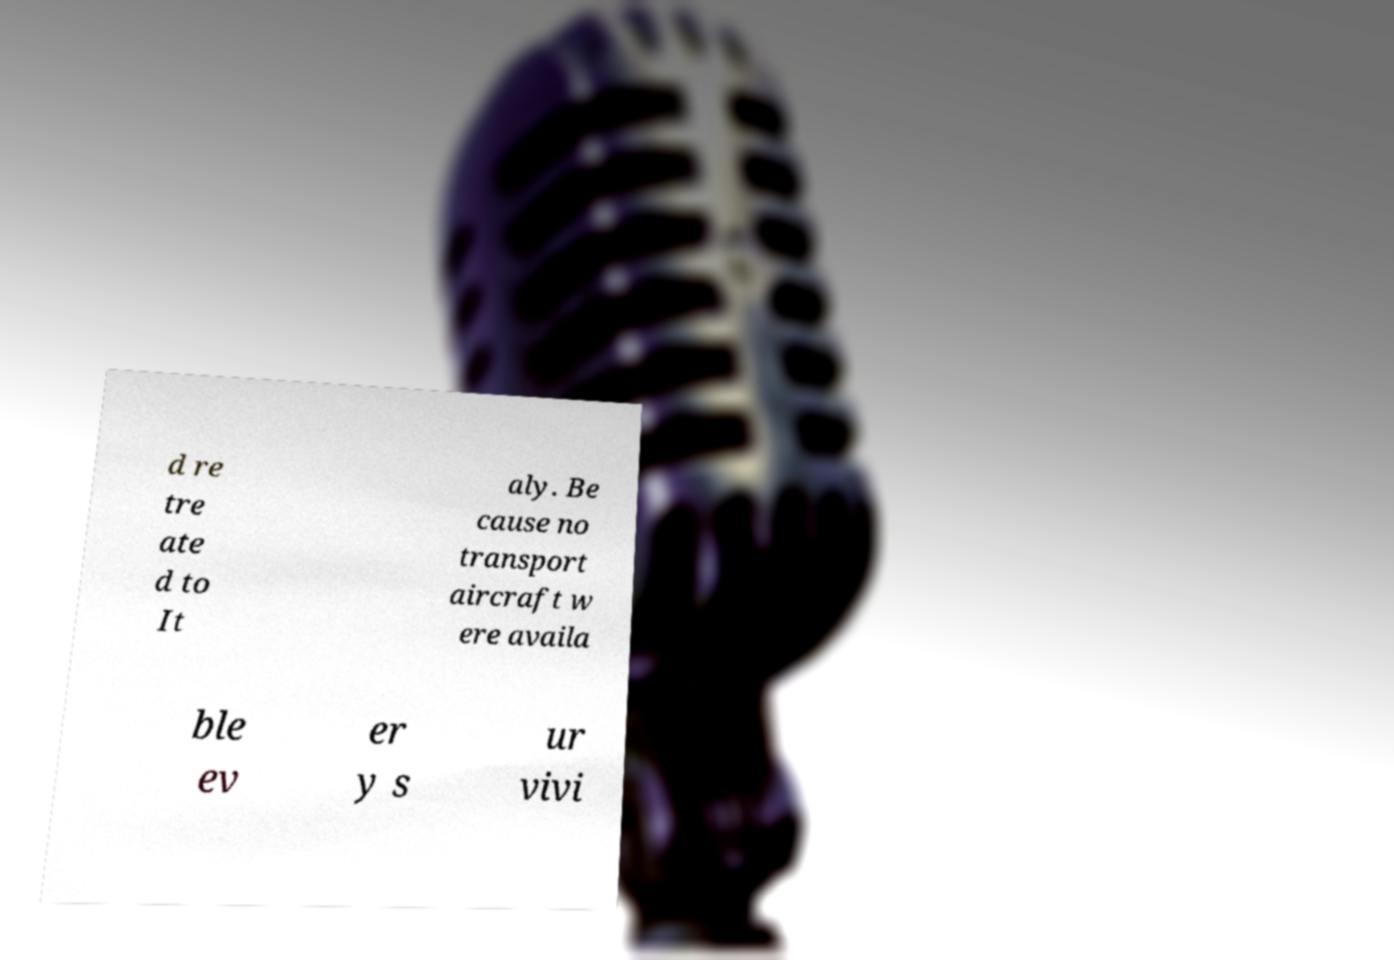Please read and relay the text visible in this image. What does it say? d re tre ate d to It aly. Be cause no transport aircraft w ere availa ble ev er y s ur vivi 